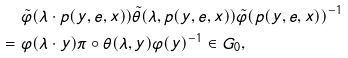Convert formula to latex. <formula><loc_0><loc_0><loc_500><loc_500>& \tilde { \varphi } ( \lambda \cdot p ( y , e , x ) ) \tilde { \theta } ( \lambda , p ( y , e , x ) ) \tilde { \varphi } ( p ( y , e , x ) ) ^ { - 1 } \\ = \ & \varphi ( \lambda \cdot y ) \pi \circ \theta ( \lambda , y ) \varphi ( y ) ^ { - 1 } \in G _ { 0 } ,</formula> 